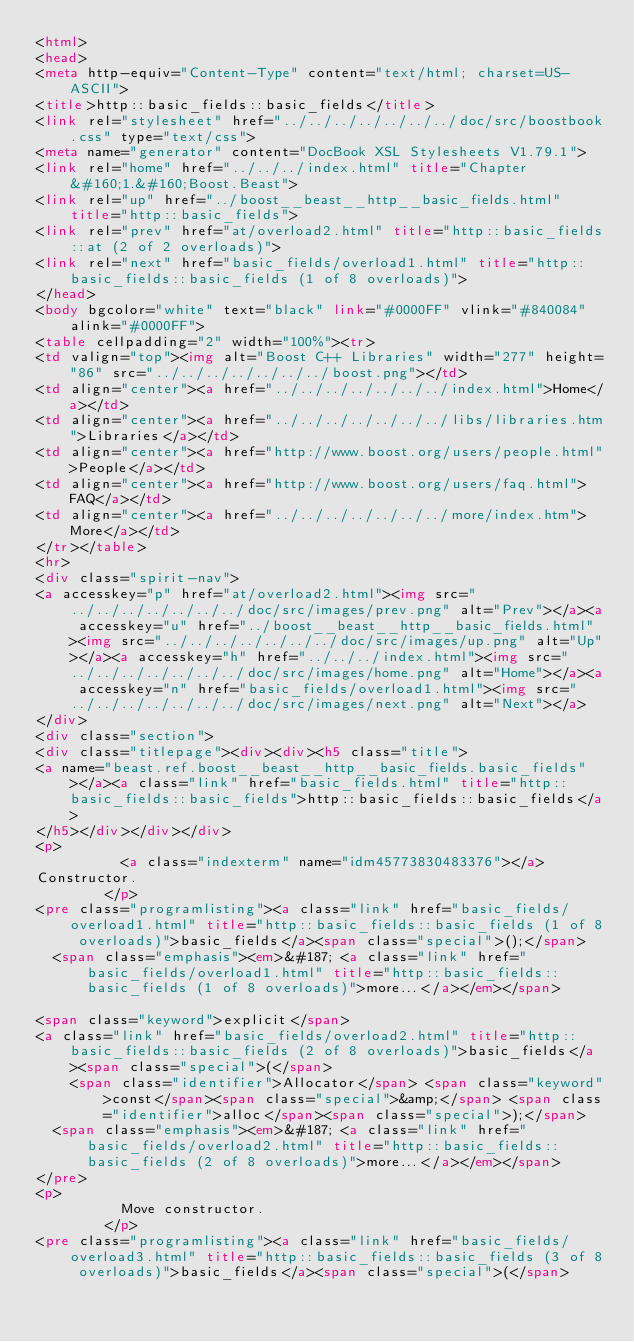Convert code to text. <code><loc_0><loc_0><loc_500><loc_500><_HTML_><html>
<head>
<meta http-equiv="Content-Type" content="text/html; charset=US-ASCII">
<title>http::basic_fields::basic_fields</title>
<link rel="stylesheet" href="../../../../../../../doc/src/boostbook.css" type="text/css">
<meta name="generator" content="DocBook XSL Stylesheets V1.79.1">
<link rel="home" href="../../../index.html" title="Chapter&#160;1.&#160;Boost.Beast">
<link rel="up" href="../boost__beast__http__basic_fields.html" title="http::basic_fields">
<link rel="prev" href="at/overload2.html" title="http::basic_fields::at (2 of 2 overloads)">
<link rel="next" href="basic_fields/overload1.html" title="http::basic_fields::basic_fields (1 of 8 overloads)">
</head>
<body bgcolor="white" text="black" link="#0000FF" vlink="#840084" alink="#0000FF">
<table cellpadding="2" width="100%"><tr>
<td valign="top"><img alt="Boost C++ Libraries" width="277" height="86" src="../../../../../../../boost.png"></td>
<td align="center"><a href="../../../../../../../index.html">Home</a></td>
<td align="center"><a href="../../../../../../../libs/libraries.htm">Libraries</a></td>
<td align="center"><a href="http://www.boost.org/users/people.html">People</a></td>
<td align="center"><a href="http://www.boost.org/users/faq.html">FAQ</a></td>
<td align="center"><a href="../../../../../../../more/index.htm">More</a></td>
</tr></table>
<hr>
<div class="spirit-nav">
<a accesskey="p" href="at/overload2.html"><img src="../../../../../../../doc/src/images/prev.png" alt="Prev"></a><a accesskey="u" href="../boost__beast__http__basic_fields.html"><img src="../../../../../../../doc/src/images/up.png" alt="Up"></a><a accesskey="h" href="../../../index.html"><img src="../../../../../../../doc/src/images/home.png" alt="Home"></a><a accesskey="n" href="basic_fields/overload1.html"><img src="../../../../../../../doc/src/images/next.png" alt="Next"></a>
</div>
<div class="section">
<div class="titlepage"><div><div><h5 class="title">
<a name="beast.ref.boost__beast__http__basic_fields.basic_fields"></a><a class="link" href="basic_fields.html" title="http::basic_fields::basic_fields">http::basic_fields::basic_fields</a>
</h5></div></div></div>
<p>
          <a class="indexterm" name="idm45773830483376"></a>
Constructor.
        </p>
<pre class="programlisting"><a class="link" href="basic_fields/overload1.html" title="http::basic_fields::basic_fields (1 of 8 overloads)">basic_fields</a><span class="special">();</span>
  <span class="emphasis"><em>&#187; <a class="link" href="basic_fields/overload1.html" title="http::basic_fields::basic_fields (1 of 8 overloads)">more...</a></em></span>

<span class="keyword">explicit</span>
<a class="link" href="basic_fields/overload2.html" title="http::basic_fields::basic_fields (2 of 8 overloads)">basic_fields</a><span class="special">(</span>
    <span class="identifier">Allocator</span> <span class="keyword">const</span><span class="special">&amp;</span> <span class="identifier">alloc</span><span class="special">);</span>
  <span class="emphasis"><em>&#187; <a class="link" href="basic_fields/overload2.html" title="http::basic_fields::basic_fields (2 of 8 overloads)">more...</a></em></span>
</pre>
<p>
          Move constructor.
        </p>
<pre class="programlisting"><a class="link" href="basic_fields/overload3.html" title="http::basic_fields::basic_fields (3 of 8 overloads)">basic_fields</a><span class="special">(</span></code> 